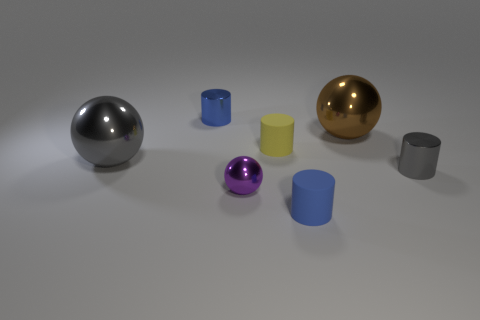Subtract 1 cylinders. How many cylinders are left? 3 Add 1 tiny shiny spheres. How many objects exist? 8 Subtract all cylinders. How many objects are left? 3 Subtract all big blue cylinders. Subtract all yellow rubber things. How many objects are left? 6 Add 6 small gray metal things. How many small gray metal things are left? 7 Add 5 purple metal spheres. How many purple metal spheres exist? 6 Subtract 0 red cylinders. How many objects are left? 7 